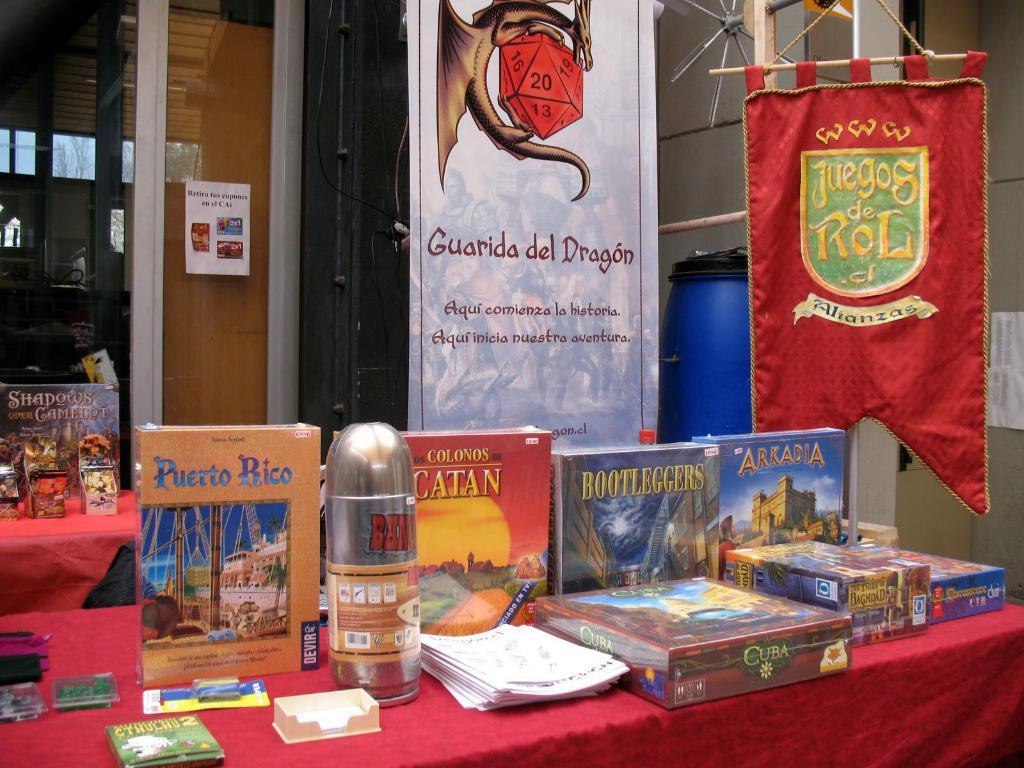<image>
Describe the image concisely. a brown Puerto Rico book on a red stand 